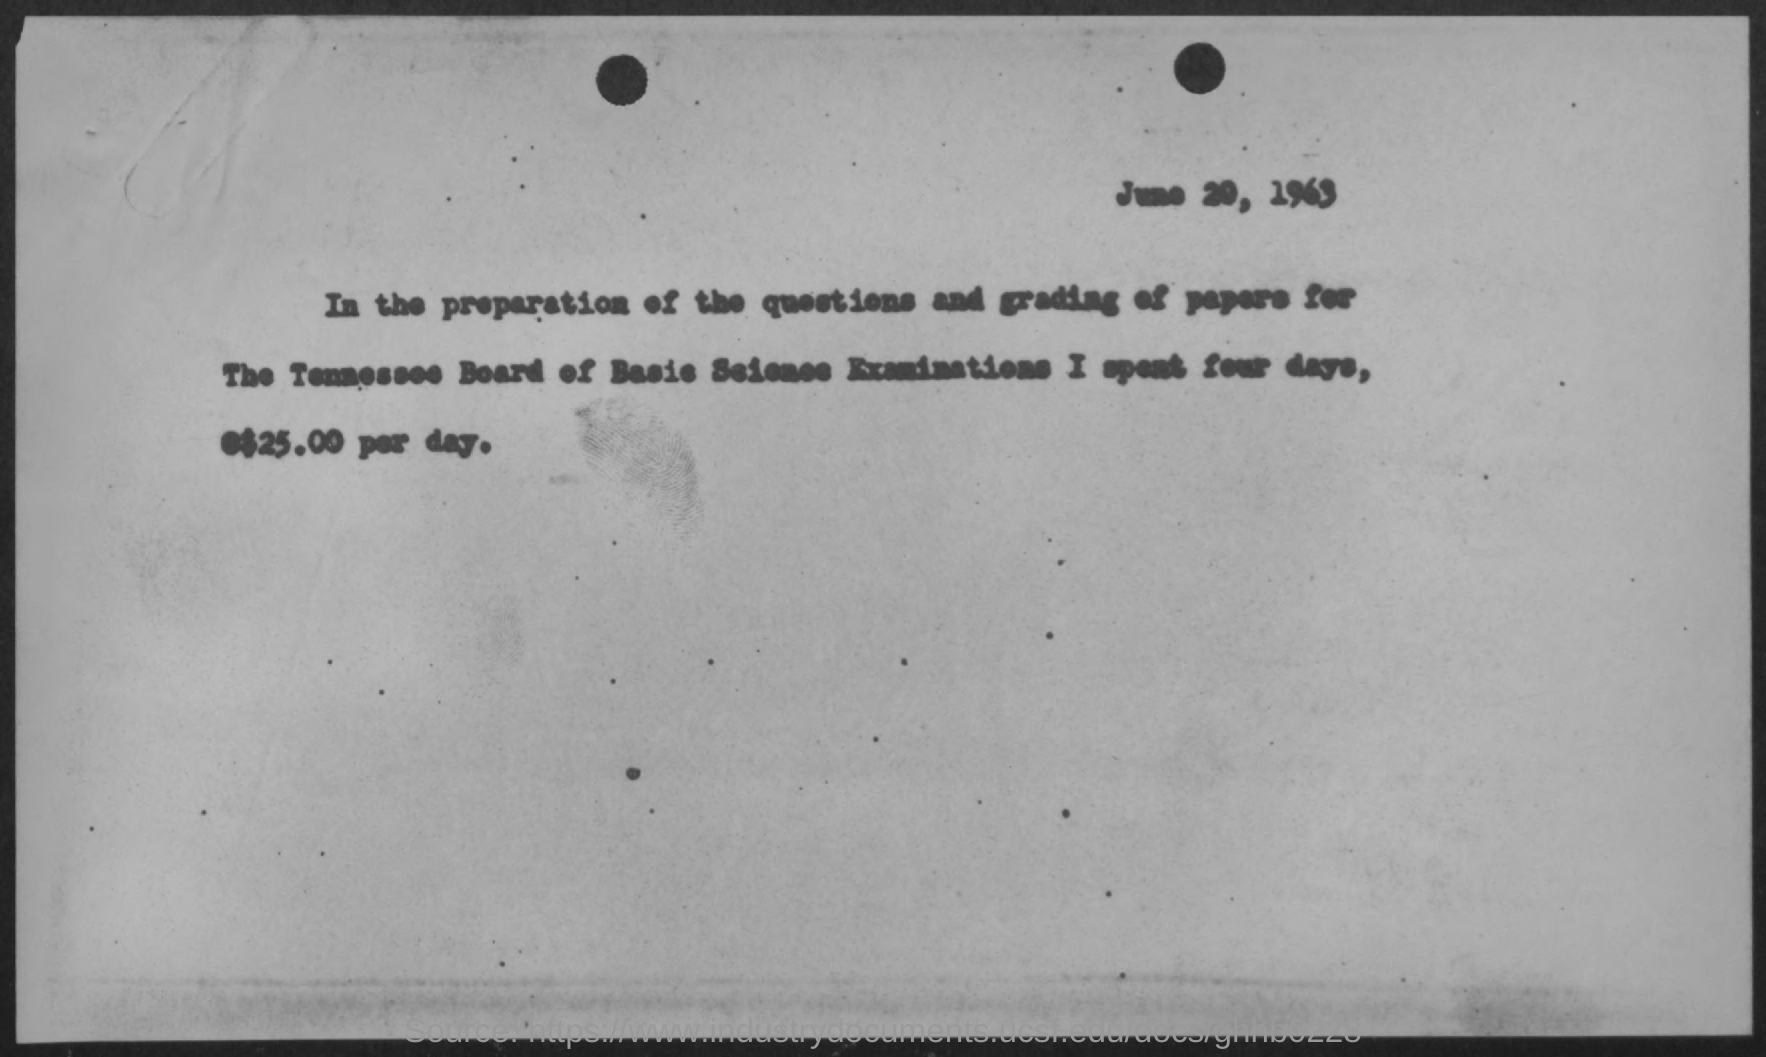What is the year given at the top?
Give a very brief answer. 1963. 